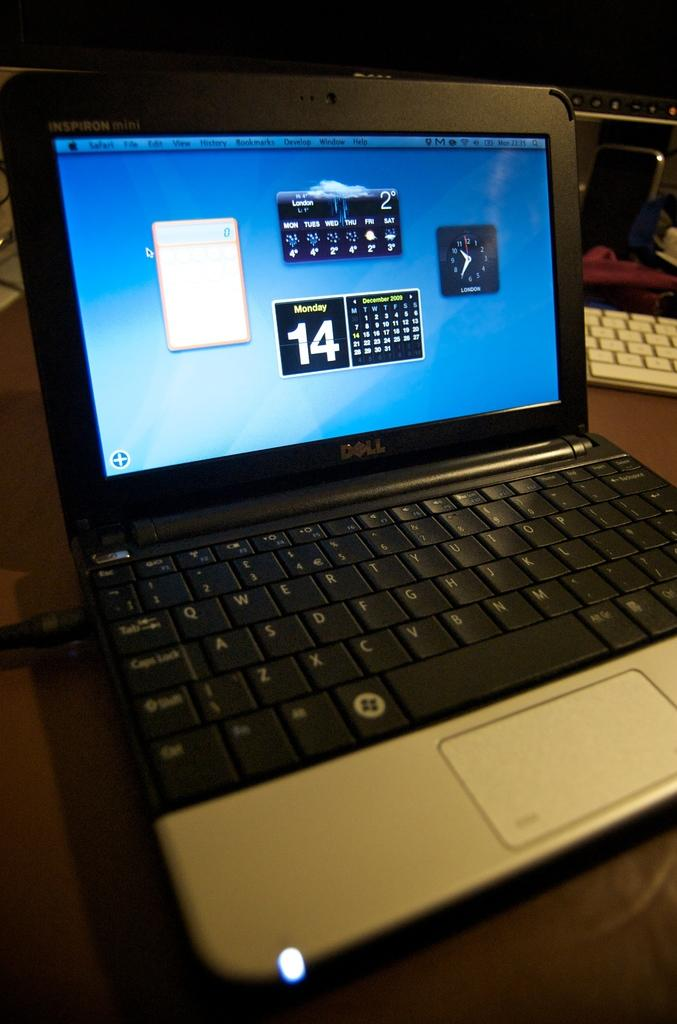What electronic device is on the table in the image? There is a laptop on a table in the image. What is visible on the laptop's screen? The laptop's screen displays icons. Can you describe the background of the image? There is another laptop on a table in the background. How many eyes can be seen on the rabbit in the image? There is no rabbit present in the image, so it is not possible to determine the number of eyes. 